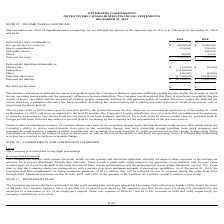According to Optimizerx Corporation's financial document, What is the ultimate realization of deferred tax assets dependent on? the Company’s ability to generate sufficient taxable income during the periods in which the net operating losses expire and the temporary differences become deductible. The document states: "lization of deferred tax assets is dependent upon the Company’s ability to generate sufficient taxable income during the periods in which the net oper..." Also, Which tax years remain open for potential audit by the Internal Revenue Service? According to the financial document, 2016 to 2019. The relevant text states: "as projections for future periods. The tax years 2016 to 2019 remain open for potential audit by the Internal Revenue Service. There are no uncertain tax positio..." Also, How much are the deferred tax liabilities in 2018 and 2019, respectively? The document shows two values: $(2,952,000) and $(4,195,000). Also, can you calculate: What is the percentage change in deferred tax assets in 2019 compared to 2018? To answer this question, I need to perform calculations using the financial data. The calculation is: (4,195,000-2,952,000)/2,952,000 , which equals 42.11 (percentage). This is based on the information: "Deferred tax asset $ 4,195,000 $ 2,952,000 Deferred tax asset $ 4,195,000 $ 2,952,000..." The key data points involved are: 2,952,000, 4,195,000. Also, can you calculate: What is the proportion of stock compensation and intangible assets over deferred tax assets in 2018? To answer this question, I need to perform calculations using the financial data. The calculation is: (535,000+124,000)/2,952,000 , which equals 0.22. This is based on the information: "Deferred tax asset $ 4,195,000 $ 2,952,000 Intangible Assets - 124,000 Stock compensation 320,000 535,000..." The key data points involved are: 124,000, 2,952,000, 535,000. Also, can you calculate: What is the average net operating loss carryover from 2018 to 2019? To answer this question, I need to perform calculations using the financial data. The calculation is: (3,839,000+2,290,000)/2 , which equals 3064500. This is based on the information: "Net operating loss carryover $ 3,839,000 $ 2,290,000 Net operating loss carryover $ 3,839,000 $ 2,290,000..." The key data points involved are: 2,290,000, 3,839,000. 